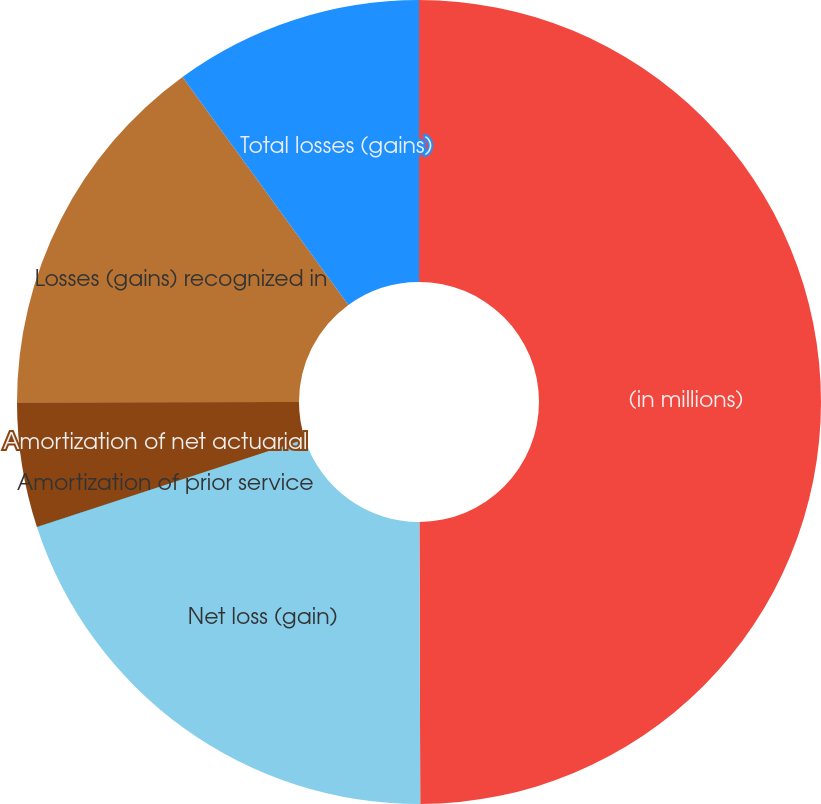<chart> <loc_0><loc_0><loc_500><loc_500><pie_chart><fcel>(in millions)<fcel>Net loss (gain)<fcel>Amortization of prior service<fcel>Amortization of net actuarial<fcel>Losses (gains) recognized in<fcel>Total losses (gains)<nl><fcel>49.95%<fcel>20.0%<fcel>0.02%<fcel>5.02%<fcel>15.0%<fcel>10.01%<nl></chart> 